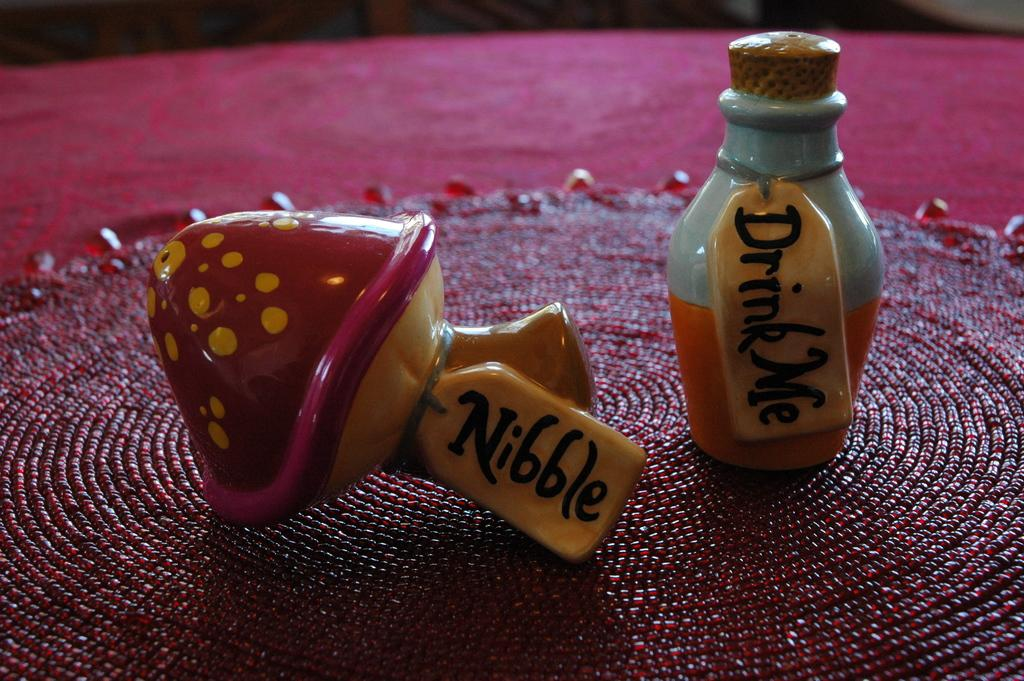<image>
Write a terse but informative summary of the picture. Colorful ceramic pieces say "Nibble" and "drink me." 